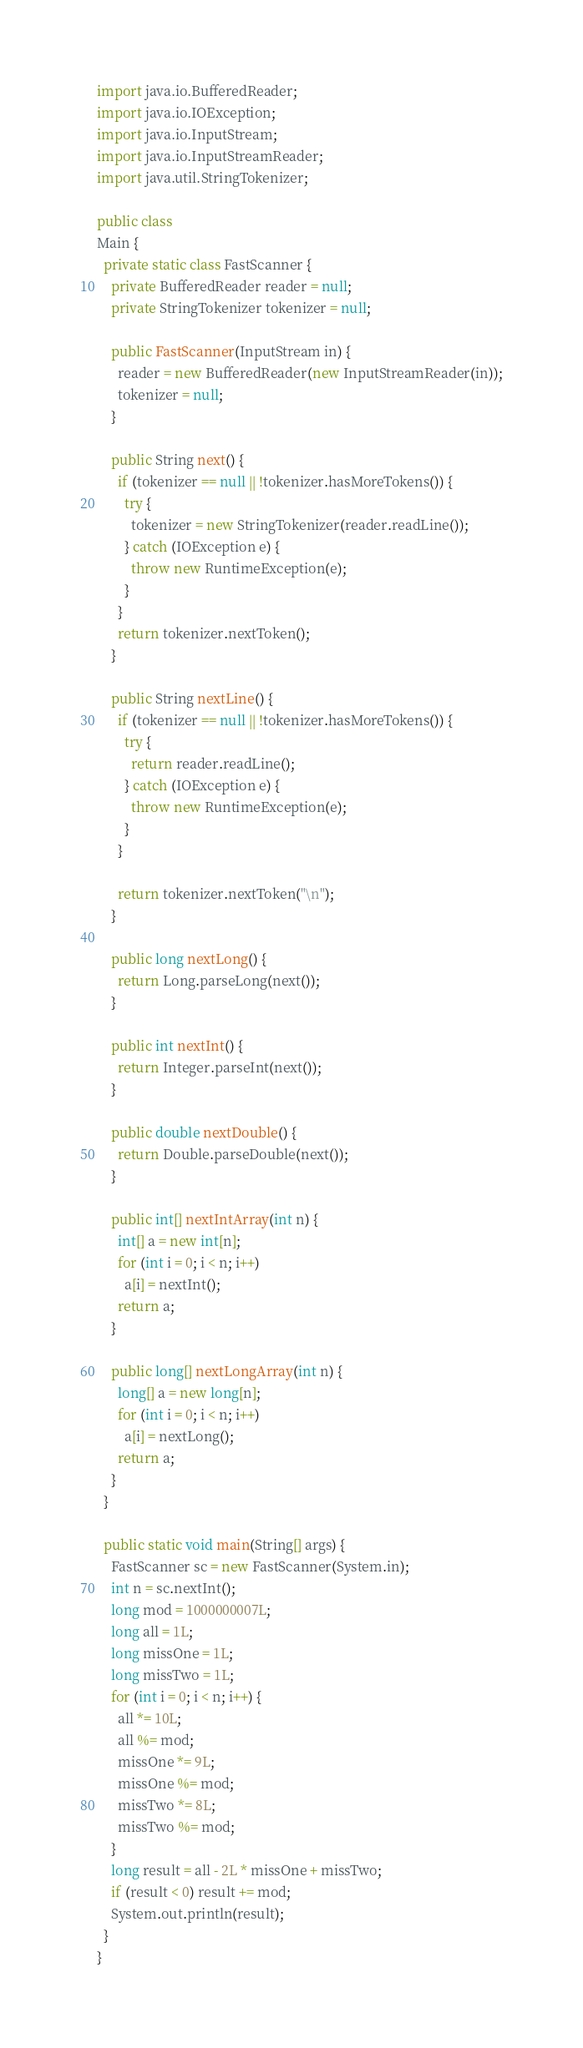<code> <loc_0><loc_0><loc_500><loc_500><_Java_>import java.io.BufferedReader;
import java.io.IOException;
import java.io.InputStream;
import java.io.InputStreamReader;
import java.util.StringTokenizer;

public class
Main {
  private static class FastScanner {
    private BufferedReader reader = null;
    private StringTokenizer tokenizer = null;

    public FastScanner(InputStream in) {
      reader = new BufferedReader(new InputStreamReader(in));
      tokenizer = null;
    }

    public String next() {
      if (tokenizer == null || !tokenizer.hasMoreTokens()) {
        try {
          tokenizer = new StringTokenizer(reader.readLine());
        } catch (IOException e) {
          throw new RuntimeException(e);
        }
      }
      return tokenizer.nextToken();
    }

    public String nextLine() {
      if (tokenizer == null || !tokenizer.hasMoreTokens()) {
        try {
          return reader.readLine();
        } catch (IOException e) {
          throw new RuntimeException(e);
        }
      }

      return tokenizer.nextToken("\n");
    }

    public long nextLong() {
      return Long.parseLong(next());
    }

    public int nextInt() {
      return Integer.parseInt(next());
    }

    public double nextDouble() {
      return Double.parseDouble(next());
    }

    public int[] nextIntArray(int n) {
      int[] a = new int[n];
      for (int i = 0; i < n; i++)
        a[i] = nextInt();
      return a;
    }

    public long[] nextLongArray(int n) {
      long[] a = new long[n];
      for (int i = 0; i < n; i++)
        a[i] = nextLong();
      return a;
    }
  }

  public static void main(String[] args) {
    FastScanner sc = new FastScanner(System.in);
    int n = sc.nextInt();
    long mod = 1000000007L;
    long all = 1L;
    long missOne = 1L;
    long missTwo = 1L;
    for (int i = 0; i < n; i++) {
      all *= 10L;
      all %= mod;
      missOne *= 9L;
      missOne %= mod;
      missTwo *= 8L;
      missTwo %= mod;
    }
    long result = all - 2L * missOne + missTwo;
    if (result < 0) result += mod;
    System.out.println(result);
  }
}</code> 